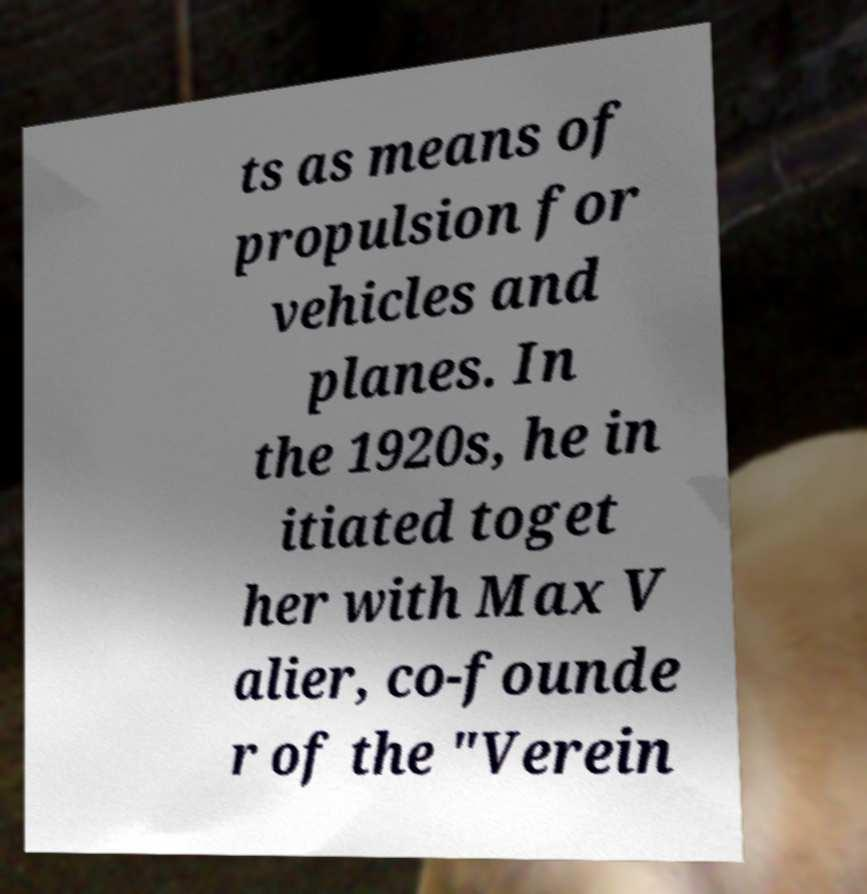Please read and relay the text visible in this image. What does it say? ts as means of propulsion for vehicles and planes. In the 1920s, he in itiated toget her with Max V alier, co-founde r of the "Verein 